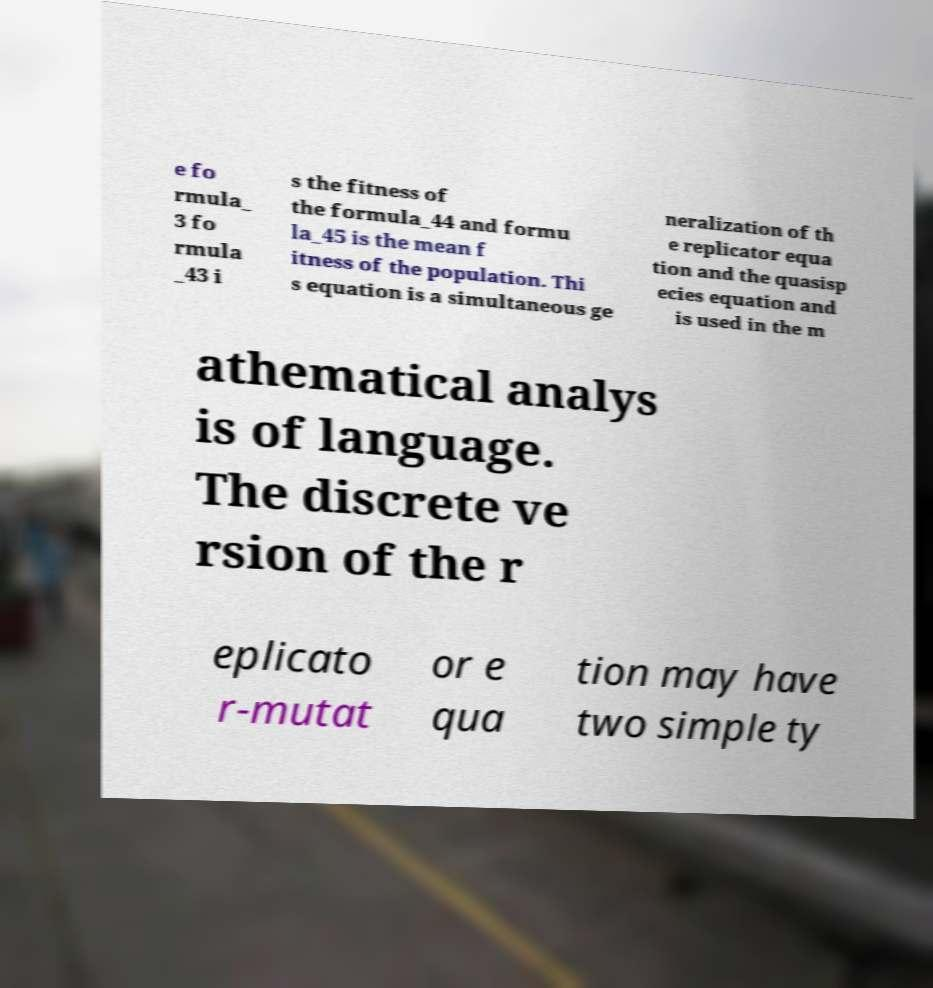Please identify and transcribe the text found in this image. e fo rmula_ 3 fo rmula _43 i s the fitness of the formula_44 and formu la_45 is the mean f itness of the population. Thi s equation is a simultaneous ge neralization of th e replicator equa tion and the quasisp ecies equation and is used in the m athematical analys is of language. The discrete ve rsion of the r eplicato r-mutat or e qua tion may have two simple ty 